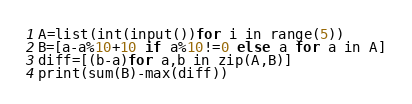<code> <loc_0><loc_0><loc_500><loc_500><_Python_>A=list(int(input())for i in range(5))
B=[a-a%10+10 if a%10!=0 else a for a in A]
diff=[(b-a)for a,b in zip(A,B)]
print(sum(B)-max(diff))
</code> 